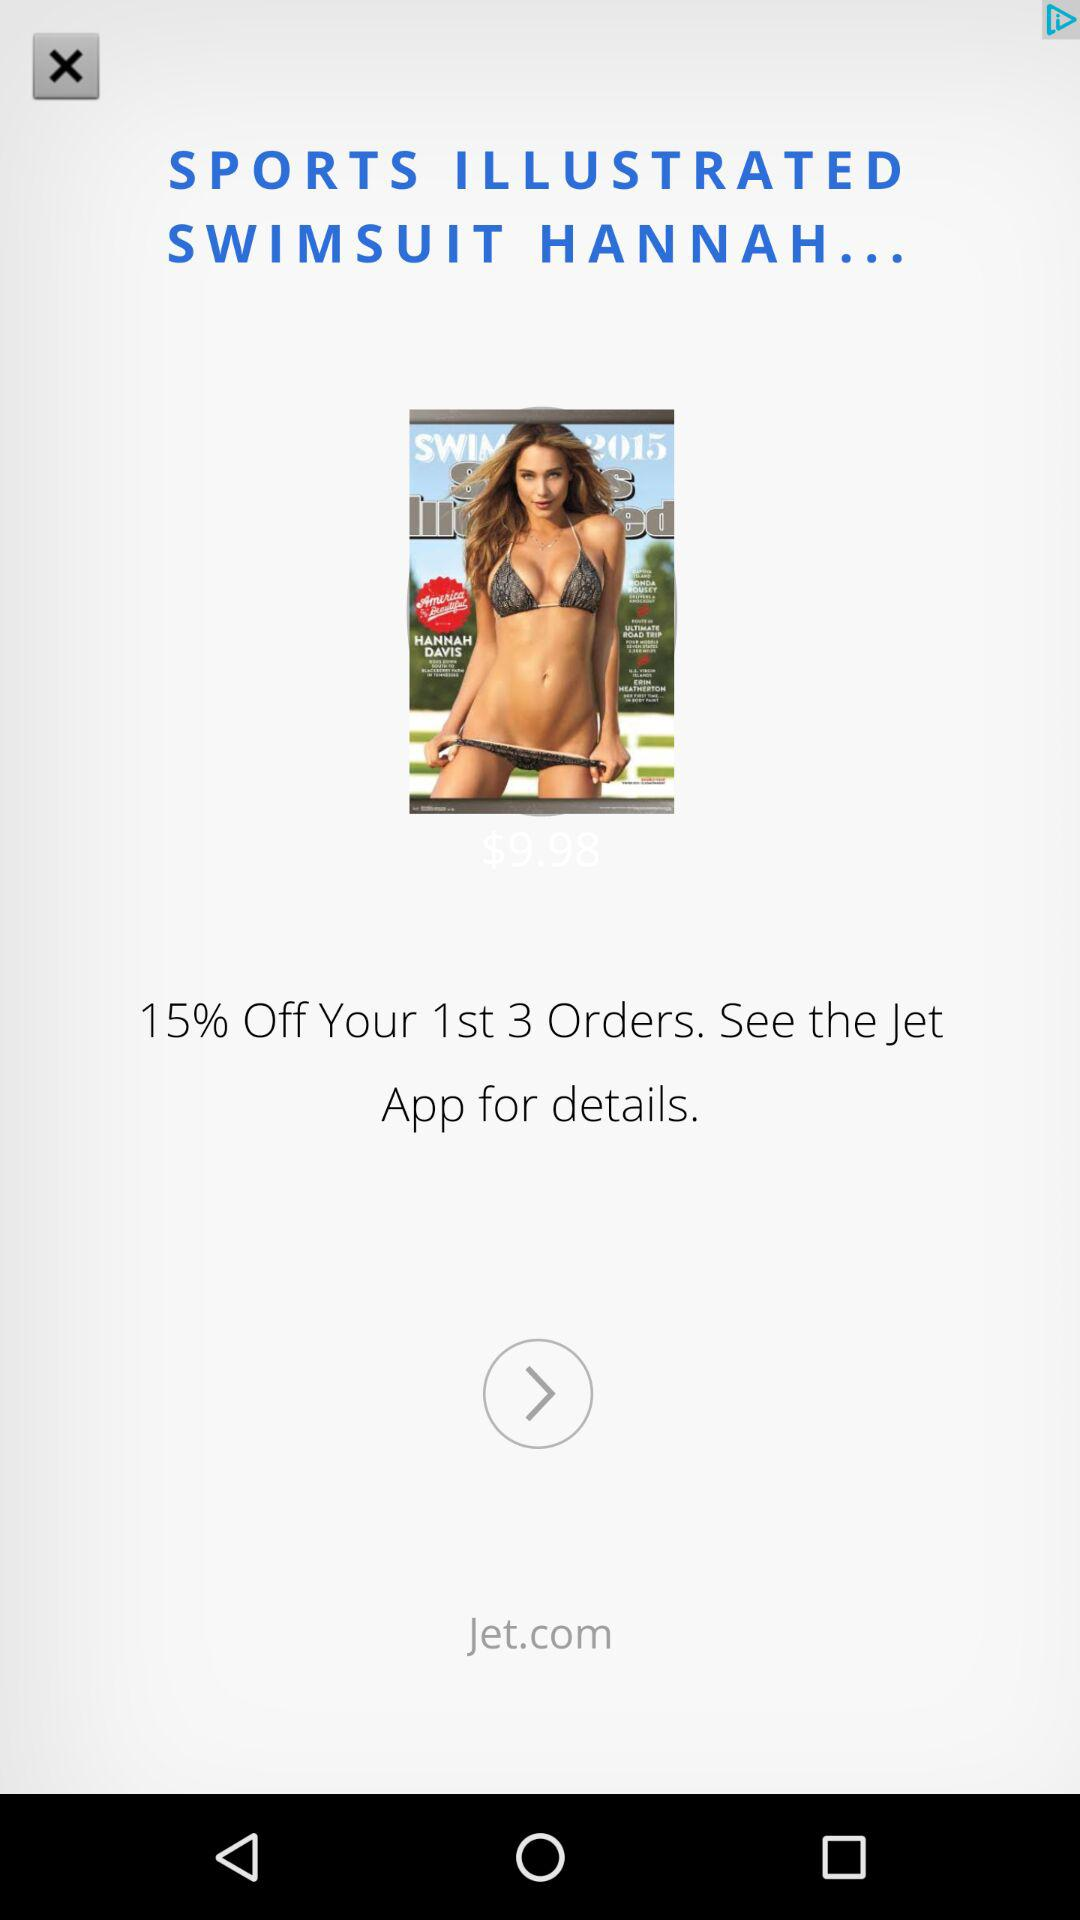What is the discount on the first 3 orders? The discount is 15% on your first 3 orders. 